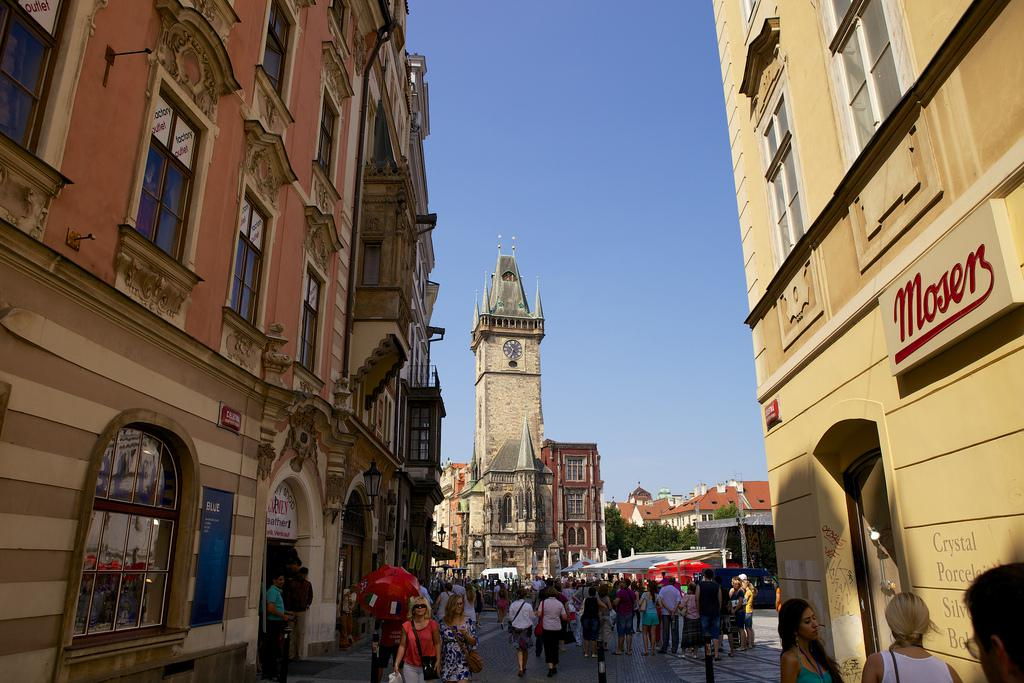Question: what is the weather condition?
Choices:
A. Clear.
B. Sunny.
C. Cloudy.
D. Gloomy.
Answer with the letter. Answer: A Question: what is the color of the words on the sign?
Choices:
A. Red.
B. Green.
C. Blue.
D. Orange.
Answer with the letter. Answer: A Question: what is the color of the building on the left?
Choices:
A. Salmon.
B. Teal.
C. Beige.
D. Brown.
Answer with the letter. Answer: C Question: where was the picture taken place?
Choices:
A. In the city.
B. On the river.
C. At the party.
D. Downtown.
Answer with the letter. Answer: D Question: who are the people?
Choices:
A. Tourists.
B. Natives.
C. Residents.
D. Employees.
Answer with the letter. Answer: A Question: what do some of the windows look like?
Choices:
A. Square shaped.
B. Scratched.
C. Arched.
D. Dirty.
Answer with the letter. Answer: C Question: what kind of building is there in the center of the picture?
Choices:
A. A short building.
B. A building with many windows.
C. A small brick building.
D. A tall building.
Answer with the letter. Answer: D Question: what are luring travelers in this picture?
Choices:
A. A street magician.
B. Shops.
C. A clown.
D. A michael jackson impersonator.
Answer with the letter. Answer: B Question: what are the tourists doing?
Choices:
A. Looking at the statue.
B. Taking pictures.
C. Eating lunch.
D. Walking around.
Answer with the letter. Answer: D Question: what type of area are people walking amongst buildings?
Choices:
A. A downtown area.
B. A shopping area.
C. A college campus.
D. An urban area.
Answer with the letter. Answer: A Question: how many clouds are in the sky?
Choices:
A. None.
B. A few.
C. Quite a bit.
D. Not that many.
Answer with the letter. Answer: A Question: what is on the building to the left?
Choices:
A. A neon light.
B. A menu.
C. A blue sign.
D. A painting.
Answer with the letter. Answer: C Question: how does the sky appear?
Choices:
A. Cloudy.
B. Sunny.
C. Clear and blue.
D. Grey.
Answer with the letter. Answer: C 